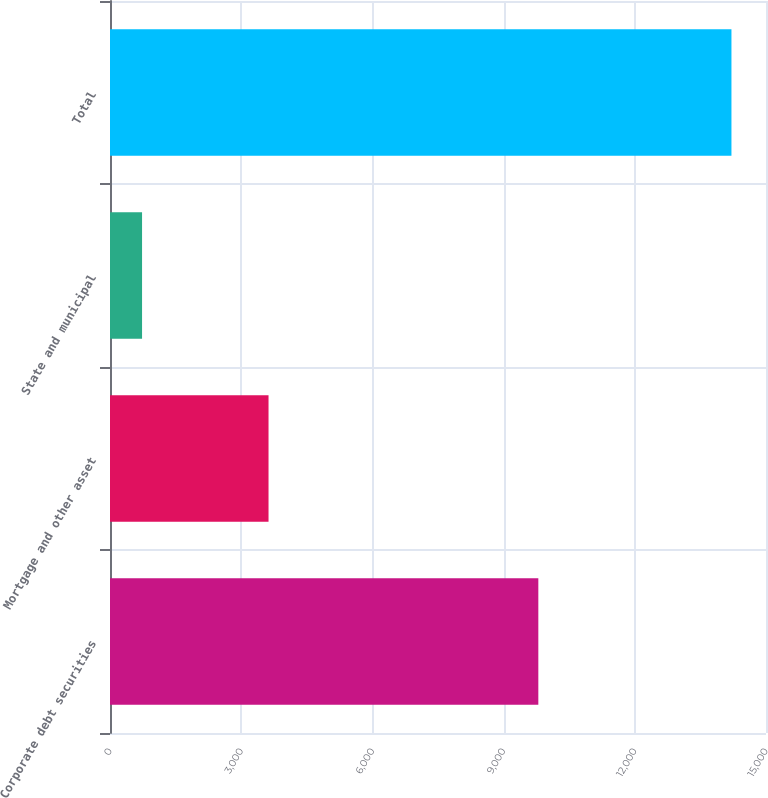Convert chart. <chart><loc_0><loc_0><loc_500><loc_500><bar_chart><fcel>Corporate debt securities<fcel>Mortgage and other asset<fcel>State and municipal<fcel>Total<nl><fcel>9794<fcel>3625<fcel>733<fcel>14210<nl></chart> 